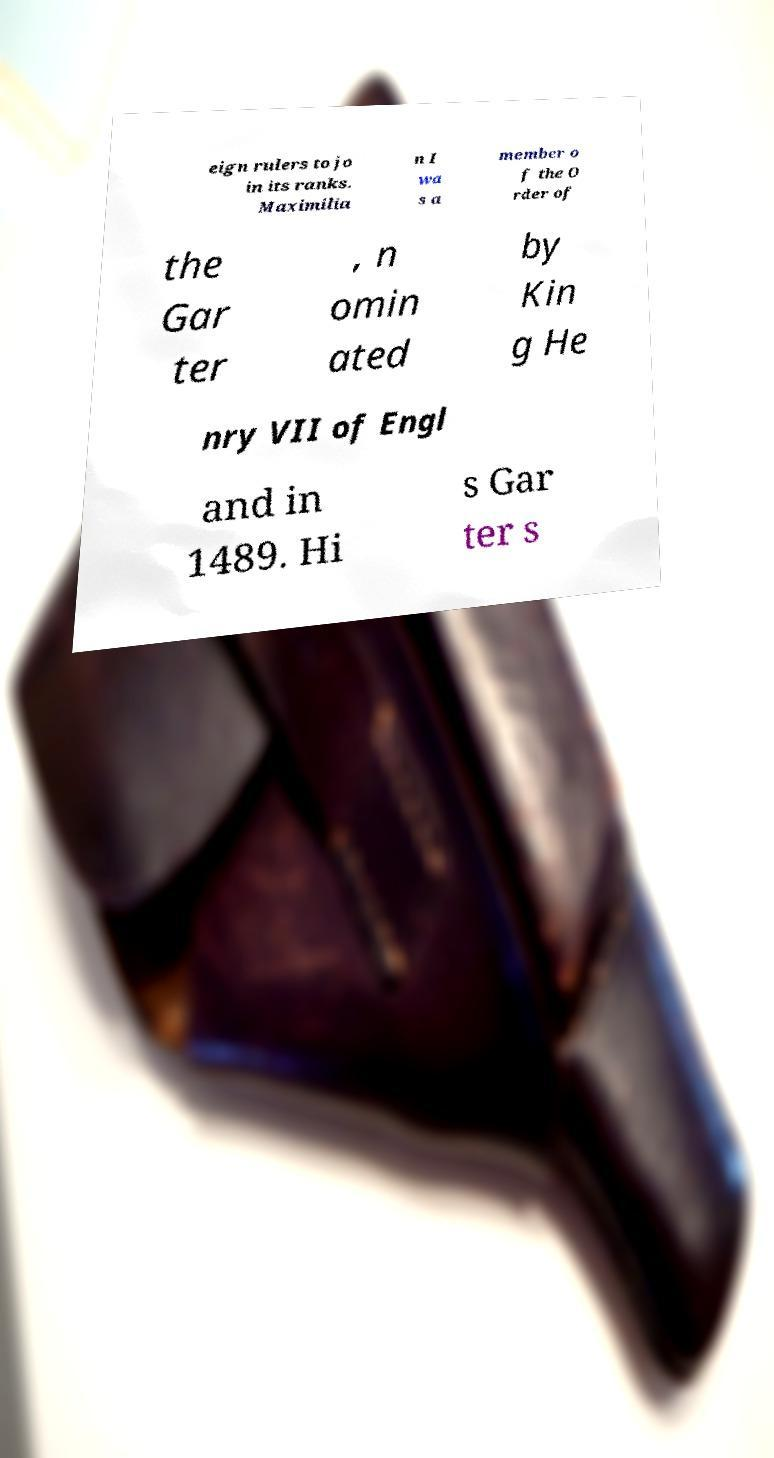Please identify and transcribe the text found in this image. eign rulers to jo in its ranks. Maximilia n I wa s a member o f the O rder of the Gar ter , n omin ated by Kin g He nry VII of Engl and in 1489. Hi s Gar ter s 